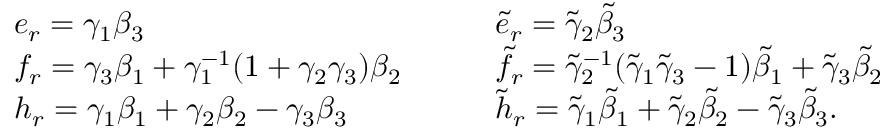<formula> <loc_0><loc_0><loc_500><loc_500>\begin{array} { l l } { e _ { r } = \gamma _ { 1 } \beta _ { 3 } } & { \tilde { e } _ { r } = \tilde { \gamma } _ { 2 } \tilde { \beta } _ { 3 } } \\ { f _ { r } = \gamma _ { 3 } \beta _ { 1 } + \gamma _ { 1 } ^ { - 1 } ( 1 + \gamma _ { 2 } \gamma _ { 3 } ) \beta _ { 2 } { \quad } } & { \tilde { f } _ { r } = \tilde { \gamma } _ { 2 } ^ { - 1 } ( \tilde { \gamma } _ { 1 } \tilde { \gamma } _ { 3 } - 1 ) \tilde { \beta } _ { 1 } + \tilde { \gamma } _ { 3 } \tilde { \beta } _ { 2 } } \\ { h _ { r } = \gamma _ { 1 } \beta _ { 1 } + \gamma _ { 2 } \beta _ { 2 } - \gamma _ { 3 } \beta _ { 3 } } & { \tilde { h } _ { r } = \tilde { \gamma } _ { 1 } \tilde { \beta } _ { 1 } + \tilde { \gamma } _ { 2 } \tilde { \beta } _ { 2 } - \tilde { \gamma } _ { 3 } \tilde { \beta } _ { 3 } . } \end{array}</formula> 